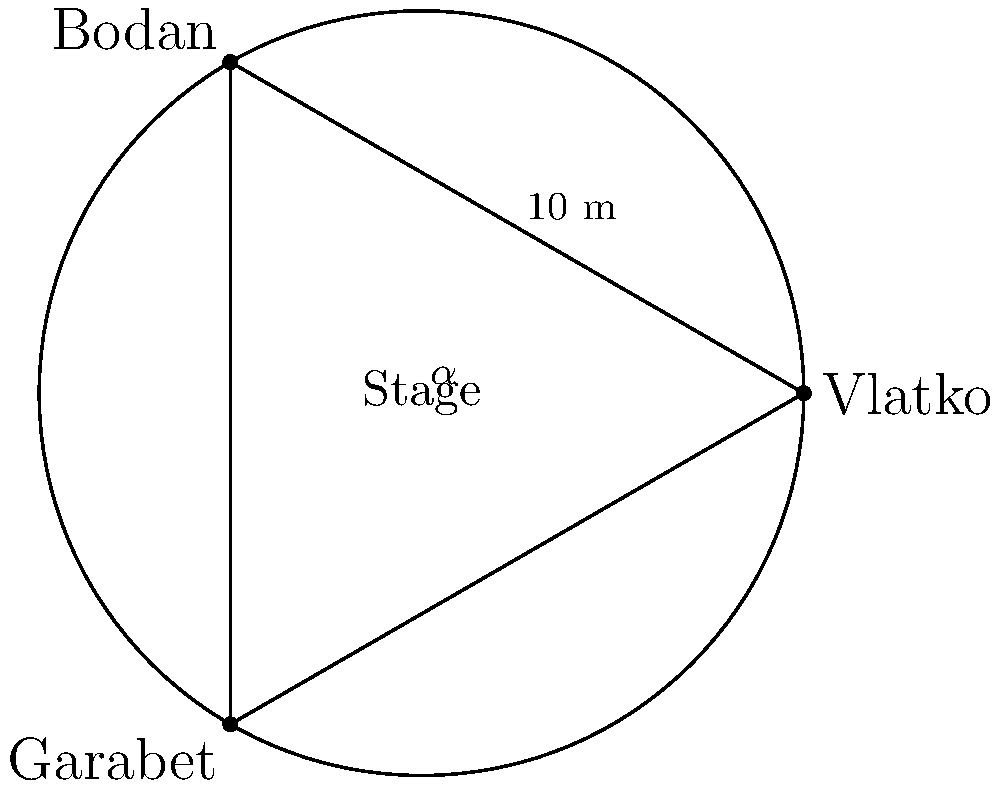At a Leb i Sol reunion concert, three original members - Vlatko, Bodan, and Garabet - are performing on a circular stage with a diameter of 10 meters. Vlatko and Bodan are positioned 10 meters apart on the edge of the stage, forming an inscribed angle $\alpha$ at the center. If Garabet is positioned at the third vertex of the equilateral triangle formed by the three musicians, what is the distance between Vlatko and Garabet to the nearest tenth of a meter? Let's approach this step-by-step:

1) First, we need to find the measure of angle $\alpha$. In an equilateral triangle, each angle measures 60°. The inscribed angle $\alpha$ is half of the central angle, so:

   $\alpha = 60° / 2 = 30°$

2) Now we can use the law of cosines to find the distance between Vlatko and Garabet. Let's call this distance $c$. The law of cosines states:

   $c^2 = a^2 + b^2 - 2ab \cos(C)$

   Where $a$ and $b$ are the other two sides (both radius of the circle), and $C$ is the angle opposite to side $c$.

3) We know:
   - $a = b = 5$ meters (radius of the stage)
   - $C = 180° - 30° = 150°$ (opposite angle to $c$)

4) Plugging these into the law of cosines:

   $c^2 = 5^2 + 5^2 - 2(5)(5) \cos(150°)$

5) Simplify:
   $c^2 = 25 + 25 - 50 \cos(150°)$
   $c^2 = 50 - 50 \cos(150°)$

6) $\cos(150°) = -\frac{\sqrt{3}}{2}$, so:

   $c^2 = 50 - 50(-\frac{\sqrt{3}}{2}) = 50 + 25\sqrt{3}$

7) Take the square root of both sides:

   $c = \sqrt{50 + 25\sqrt{3}} \approx 8.7$ meters

8) Rounding to the nearest tenth:

   $c \approx 8.7$ meters
Answer: 8.7 meters 